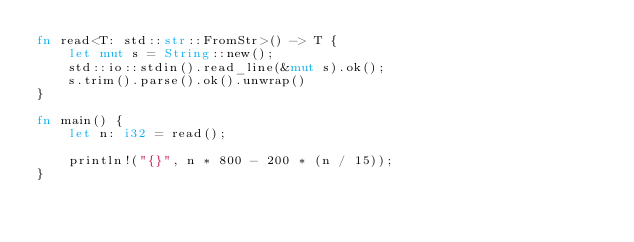<code> <loc_0><loc_0><loc_500><loc_500><_Rust_>fn read<T: std::str::FromStr>() -> T {
    let mut s = String::new();
    std::io::stdin().read_line(&mut s).ok();
    s.trim().parse().ok().unwrap()
}

fn main() {
    let n: i32 = read();

    println!("{}", n * 800 - 200 * (n / 15));
}
</code> 